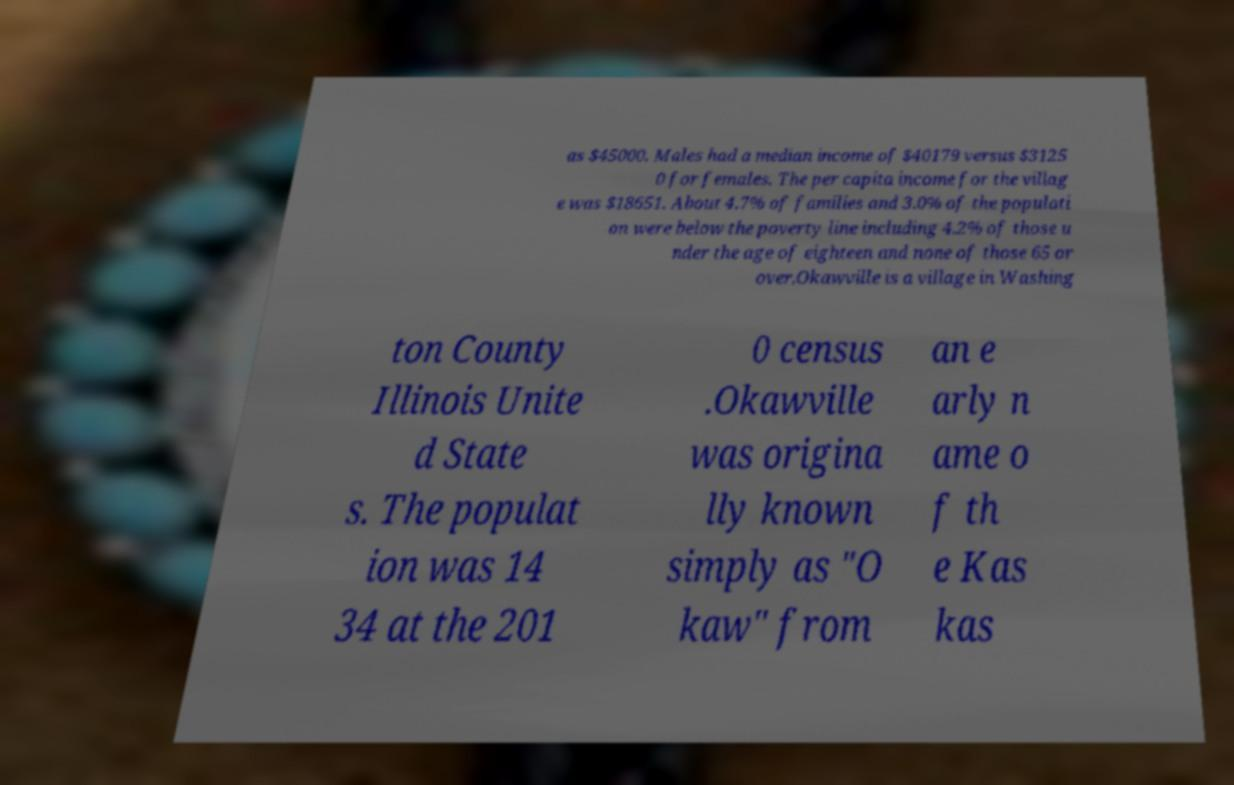Could you assist in decoding the text presented in this image and type it out clearly? as $45000. Males had a median income of $40179 versus $3125 0 for females. The per capita income for the villag e was $18651. About 4.7% of families and 3.0% of the populati on were below the poverty line including 4.2% of those u nder the age of eighteen and none of those 65 or over.Okawville is a village in Washing ton County Illinois Unite d State s. The populat ion was 14 34 at the 201 0 census .Okawville was origina lly known simply as "O kaw" from an e arly n ame o f th e Kas kas 